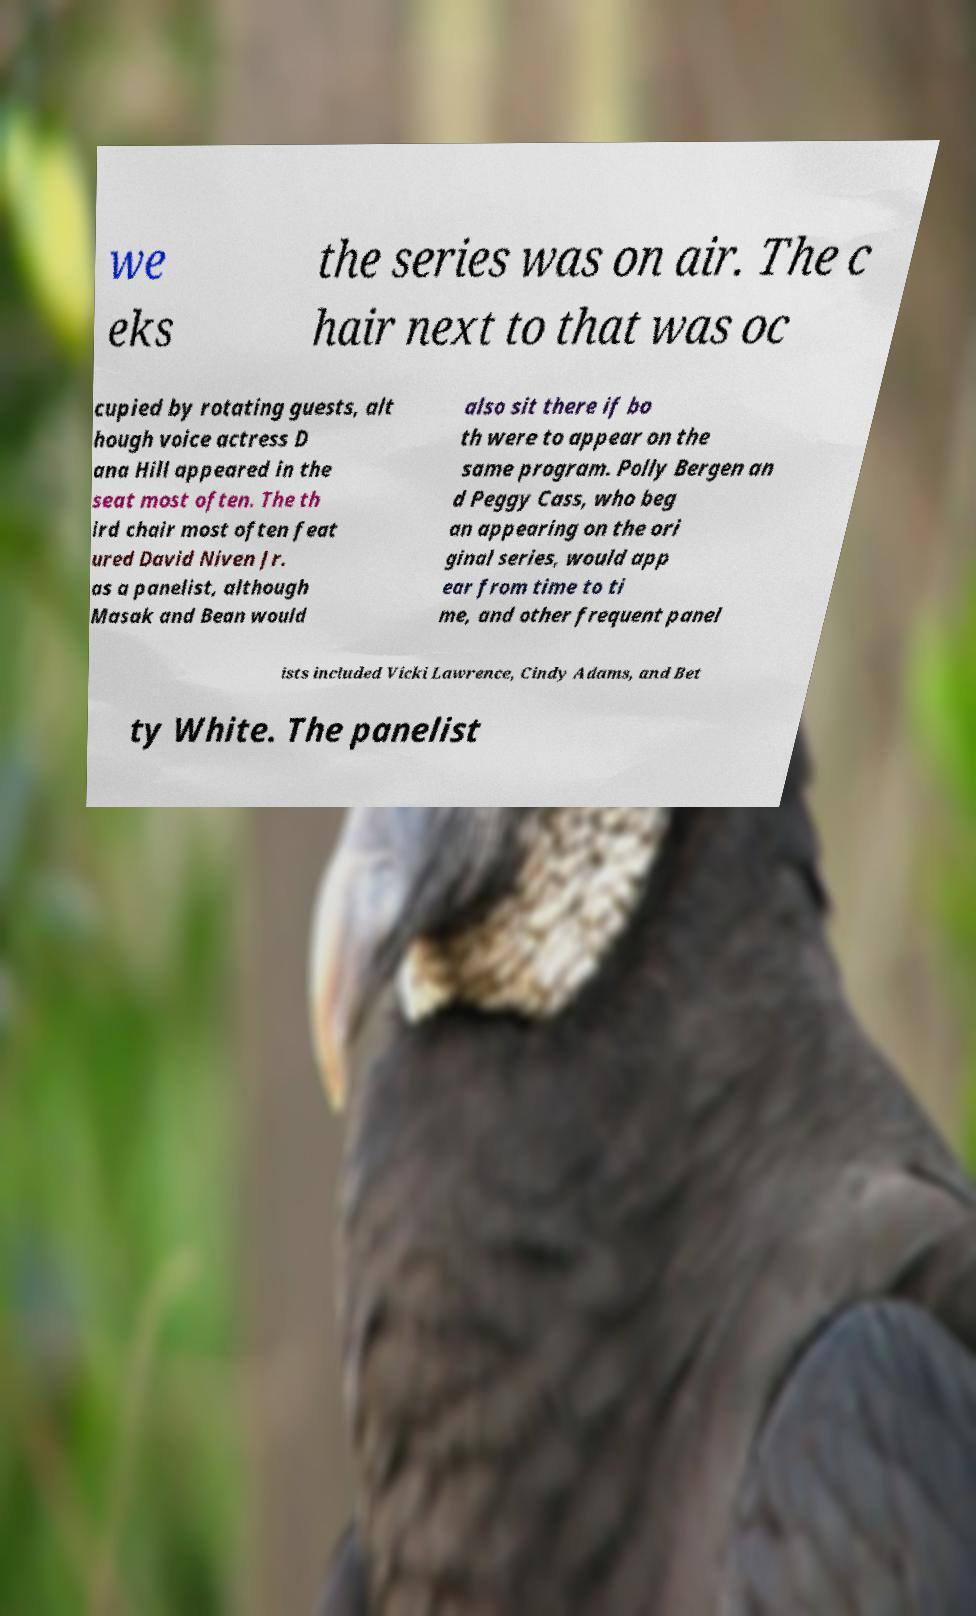Please read and relay the text visible in this image. What does it say? we eks the series was on air. The c hair next to that was oc cupied by rotating guests, alt hough voice actress D ana Hill appeared in the seat most often. The th ird chair most often feat ured David Niven Jr. as a panelist, although Masak and Bean would also sit there if bo th were to appear on the same program. Polly Bergen an d Peggy Cass, who beg an appearing on the ori ginal series, would app ear from time to ti me, and other frequent panel ists included Vicki Lawrence, Cindy Adams, and Bet ty White. The panelist 